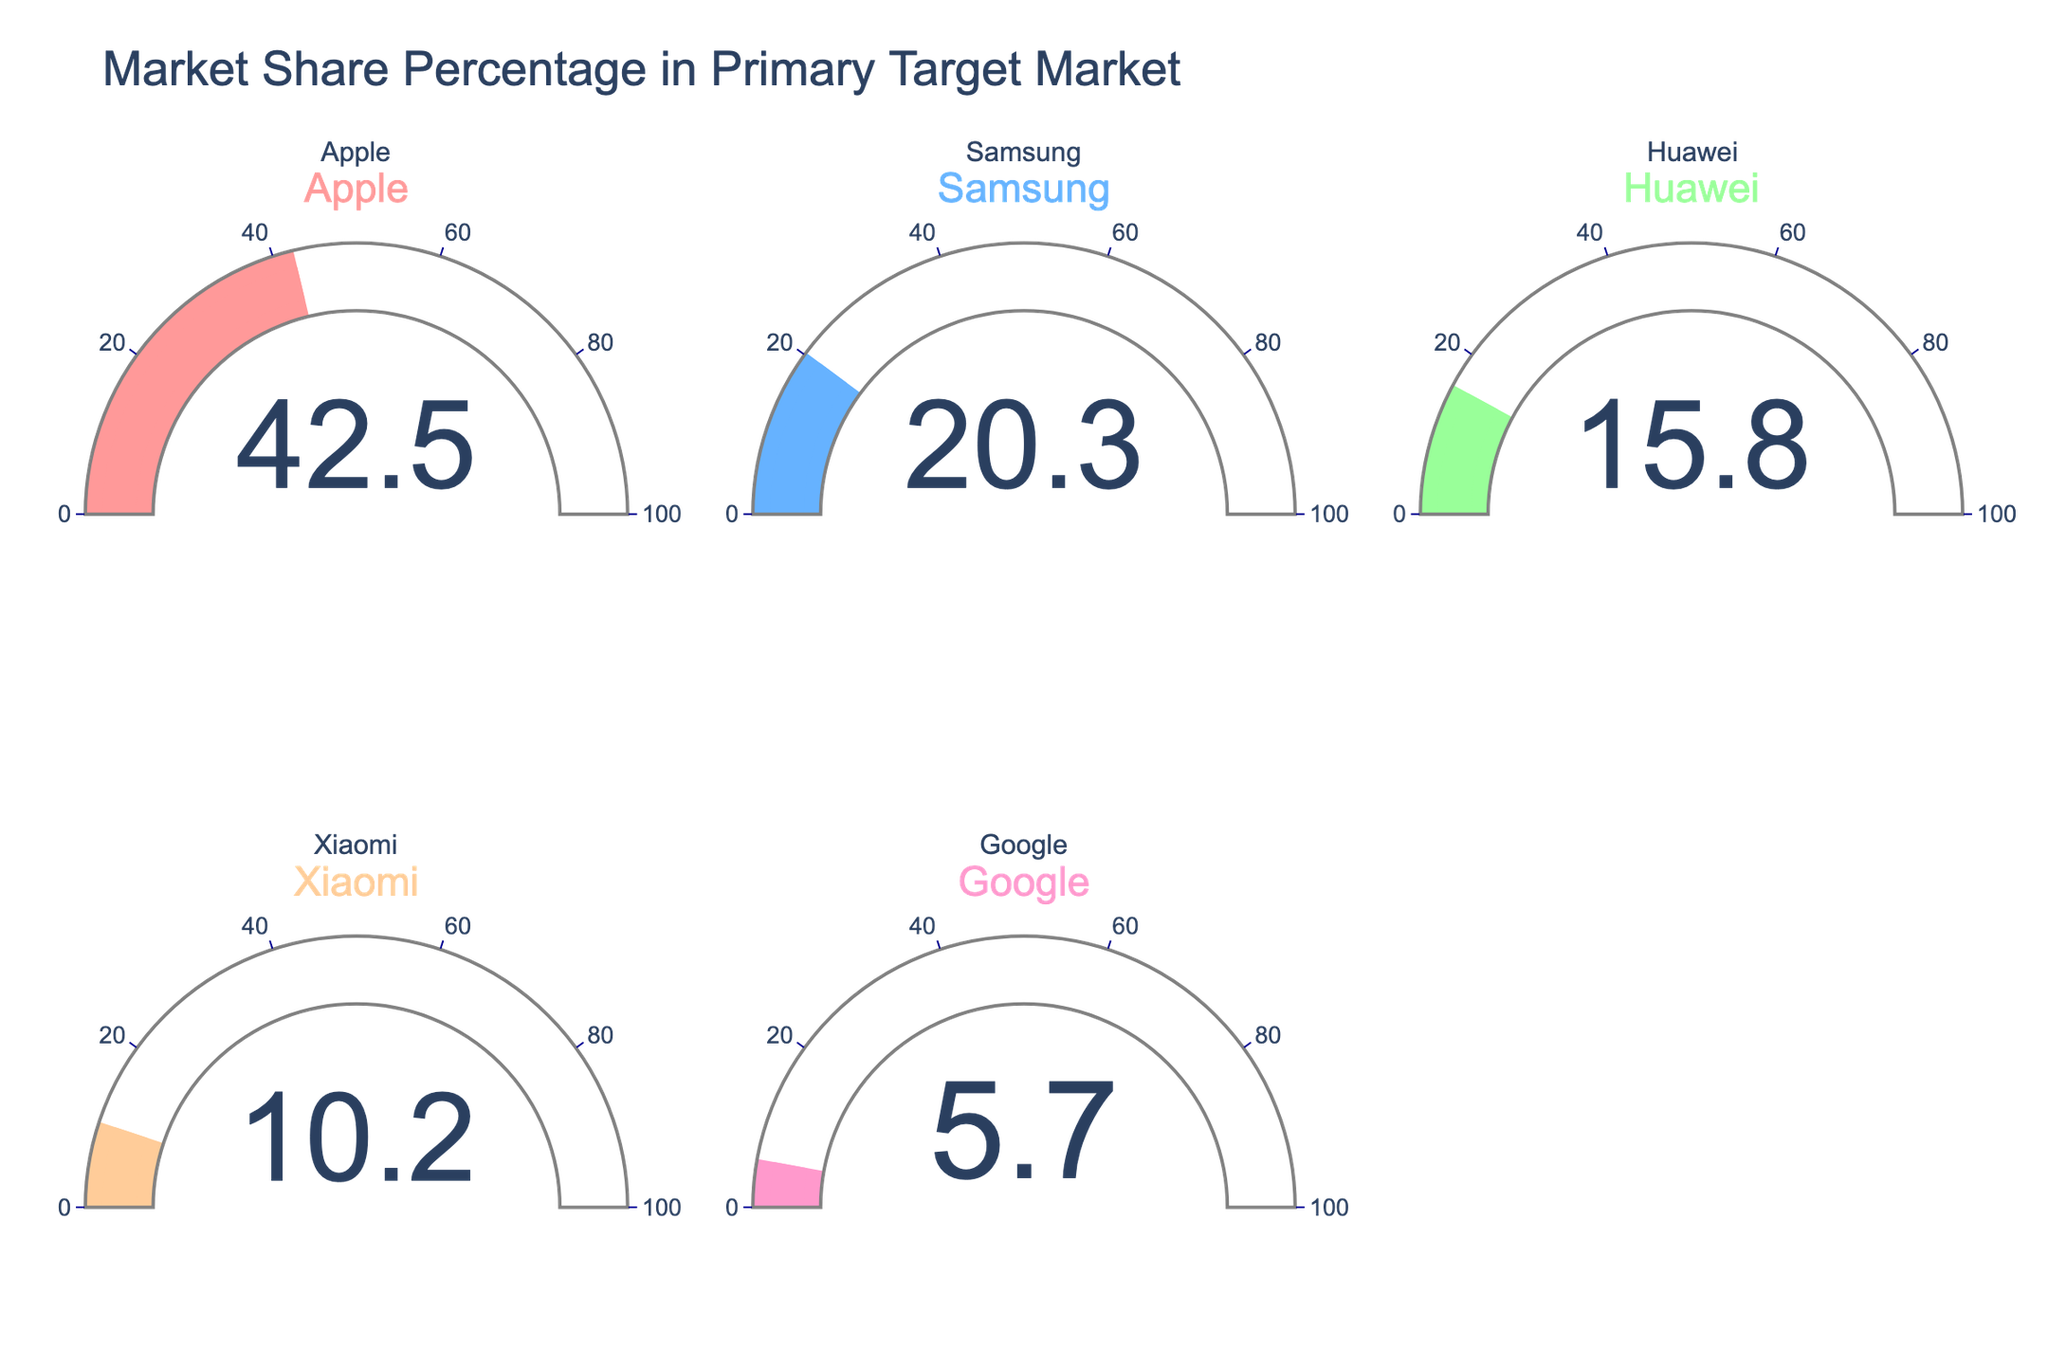What's the highest market share percentage shown on the gauge chart? The highest market share value can be identified by looking for the largest number displayed on the gauges. The gauge for Apple shows 42.5%, which is the highest.
Answer: 42.5% Comparing Apple and Samsung, which company has a greater market share? By looking at the gauge for each company, Apple shows a market share of 42.5% whereas Samsung shows 20.3%. Since 42.5% is greater than 20.3%, Apple has a greater market share.
Answer: Apple What's the difference in market share between Huawei and Xiaomi? The gauge for Huawei shows a market share of 15.8% and the gauge for Xiaomi shows 10.2%. The difference is calculated as 15.8% - 10.2%, which is 5.6%.
Answer: 5.6% What is the total market share percentage covered by all companies in the gauge chart? To find the total market share, sum the percentages shown on all the gauges: 42.5% (Apple) + 20.3% (Samsung) + 15.8% (Huawei) + 10.2% (Xiaomi) + 5.7% (Google). This gives a total of 94.5%.
Answer: 94.5% Which companies have a market share lower than 15%? Looking at the gauges, Samsung (20.3%), Apple (42.5%), and Huawei (15.8%) all have market shares above 15%. Xiaomi (10.2%) and Google (5.7%) have market shares below 15%.
Answer: Xiaomi and Google What’s the average market share percentage among the listed companies? To find the average, sum all the market share percentages and divide by the number of companies: (42.5% + 20.3% + 15.8% + 10.2% + 5.7%) / 5 = 94.5% / 5 = 18.9%.
Answer: 18.9% If Samsung’s market share increased by 5%, what would its new market share be? Samsung’s current market share is 20.3%. Adding 5% gives a new market share of 20.3% + 5% = 25.3%.
Answer: 25.3% How does Google’s market share compare to the median market share of all companies? First, arrange the market shares in ascending order: 5.7% (Google), 10.2% (Xiaomi), 15.8% (Huawei), 20.3% (Samsung), and 42.5% (Apple). The median market share is the middle value: 15.8%. Google’s market share (5.7%) is less than the median (15.8%).
Answer: Less than What proportion of the total market share does Apple hold? Apple's market share is 42.5%. The total market share of all companies is 94.5%. The proportion of Apple’s share is calculated as (42.5% / 94.5%) × 100%, which gives approximately 44.97%.
Answer: Approximately 44.97% 